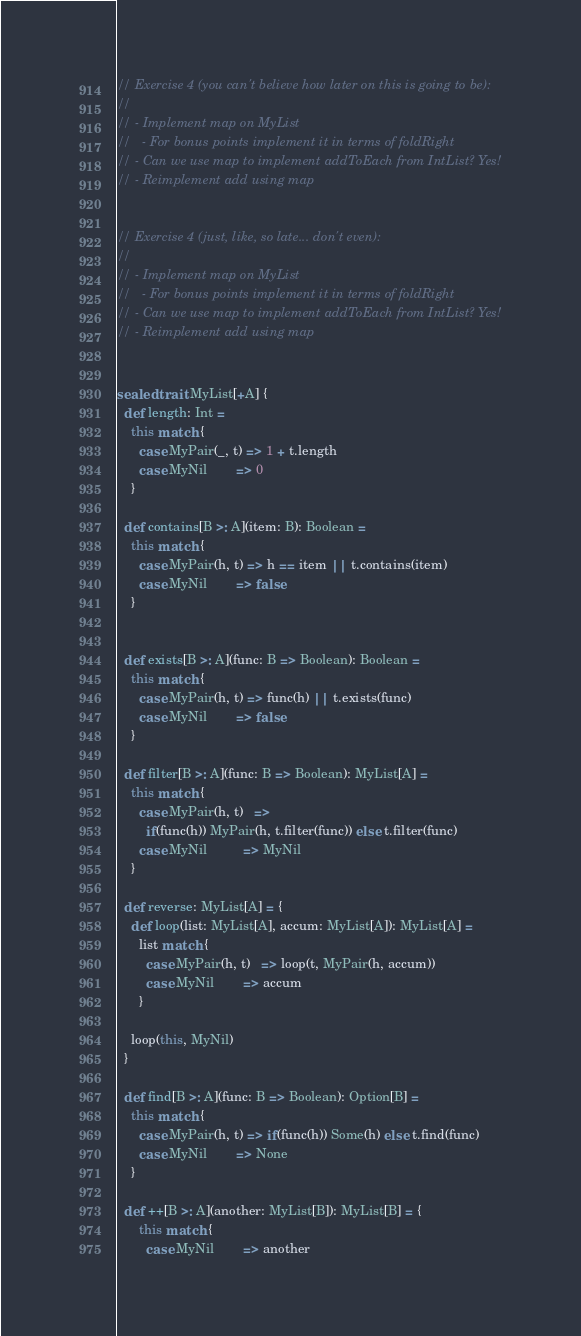<code> <loc_0><loc_0><loc_500><loc_500><_Scala_>// Exercise 4 (you can't believe how later on this is going to be):
//
// - Implement map on MyList
//   - For bonus points implement it in terms of foldRight
// - Can we use map to implement addToEach from IntList? Yes!
// - Reimplement add using map


// Exercise 4 (just, like, so late... don't even):
//
// - Implement map on MyList
//   - For bonus points implement it in terms of foldRight
// - Can we use map to implement addToEach from IntList? Yes!
// - Reimplement add using map


sealed trait MyList[+A] {
  def length: Int =
    this match {
      case MyPair(_, t) => 1 + t.length
      case MyNil        => 0
    }

  def contains[B >: A](item: B): Boolean =
    this match {
      case MyPair(h, t) => h == item || t.contains(item)
      case MyNil        => false
    }


  def exists[B >: A](func: B => Boolean): Boolean =
    this match {
      case MyPair(h, t) => func(h) || t.exists(func)
      case MyNil        => false
    }

  def filter[B >: A](func: B => Boolean): MyList[A] =
    this match {
      case MyPair(h, t)   =>
        if(func(h)) MyPair(h, t.filter(func)) else t.filter(func)
      case MyNil          => MyNil
    }

  def reverse: MyList[A] = {
    def loop(list: MyList[A], accum: MyList[A]): MyList[A] =
      list match {
        case MyPair(h, t)   => loop(t, MyPair(h, accum))
        case MyNil        => accum
      }

    loop(this, MyNil)
  }

  def find[B >: A](func: B => Boolean): Option[B] =
    this match {
      case MyPair(h, t) => if(func(h)) Some(h) else t.find(func)
      case MyNil        => None
    }

  def ++[B >: A](another: MyList[B]): MyList[B] = {
      this match {
        case MyNil        => another</code> 